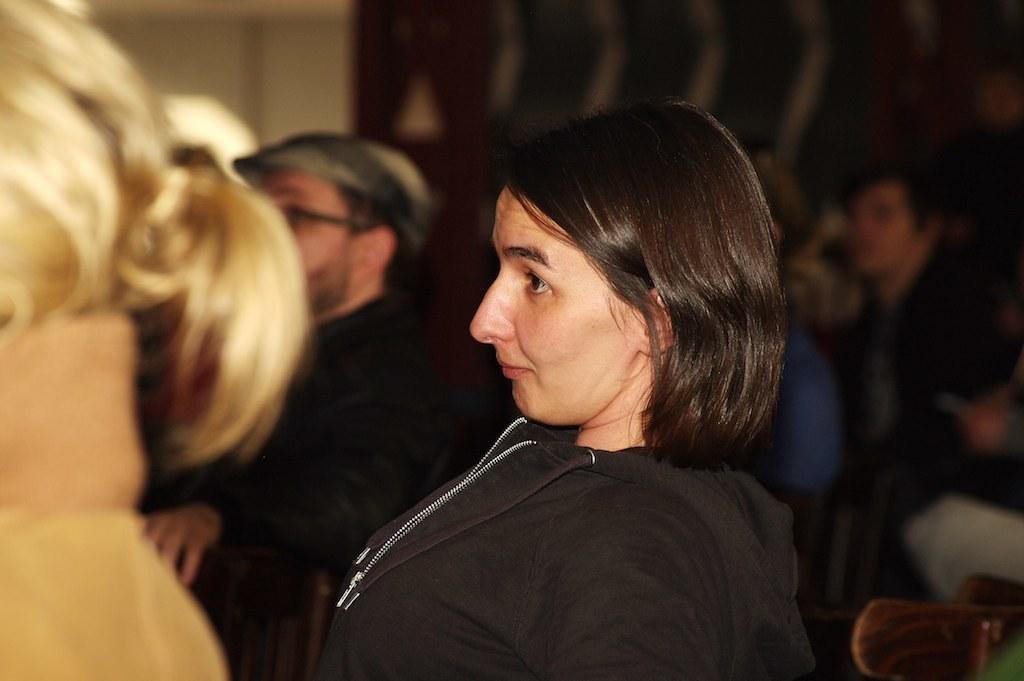Could you give a brief overview of what you see in this image? In the picture there is a woman, beside the women there are people present and there may be a wall. 